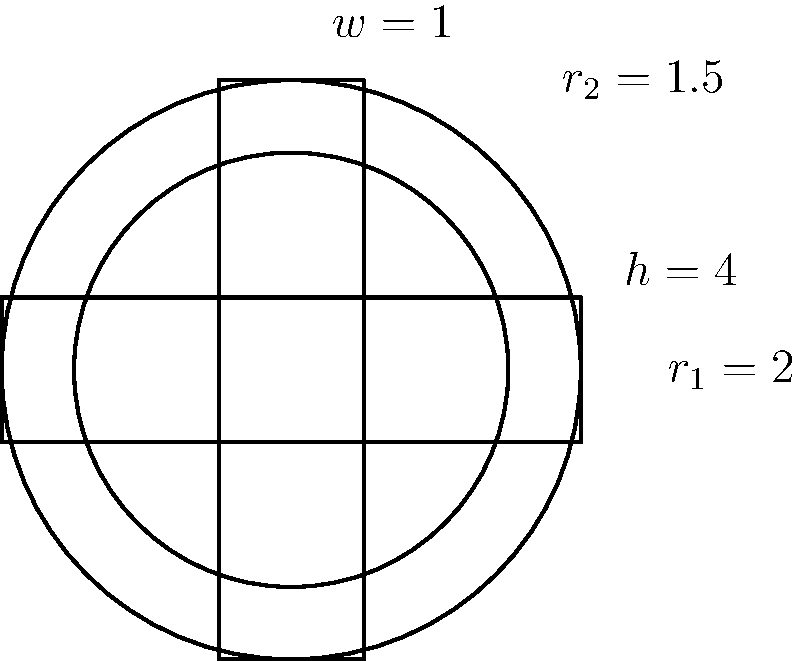In your quest to design a book cover inspired by the Covenanters era, you've created a stylized Celtic cross using intersecting circles and rectangles. The outer circle has a radius of 2 units, the inner circle has a radius of 1.5 units, and the rectangles have a width of 1 unit and a height of 4 units. Calculate the perimeter of this Celtic cross design, rounded to two decimal places. To calculate the perimeter of the Celtic cross, we need to sum the lengths of the visible arcs and line segments:

1. Outer circle arcs:
   - There are 4 arcs, each spanning 90° or $\frac{\pi}{2}$ radians
   - Arc length = $r\theta = 2 \cdot \frac{\pi}{2} = \pi$
   - Total length of outer arcs: $4\pi$

2. Inner circle arcs:
   - There are 4 arcs, each spanning 90° or $\frac{\pi}{2}$ radians
   - Arc length = $r\theta = 1.5 \cdot \frac{\pi}{2} = \frac{3\pi}{4}$
   - Total length of inner arcs: $4 \cdot \frac{3\pi}{4} = 3\pi$

3. Rectangular segments:
   - There are 8 visible line segments, each 1.5 units long
   - Total length of line segments: $8 \cdot 1.5 = 12$

The total perimeter is the sum of these parts:
$$ \text{Perimeter} = 4\pi + 3\pi + 12 = 7\pi + 12 $$

Calculating the numeric value:
$$ 7\pi + 12 \approx 7 \cdot 3.14159 + 12 \approx 34.00 $$

Rounding to two decimal places gives 34.00 units.
Answer: 34.00 units 